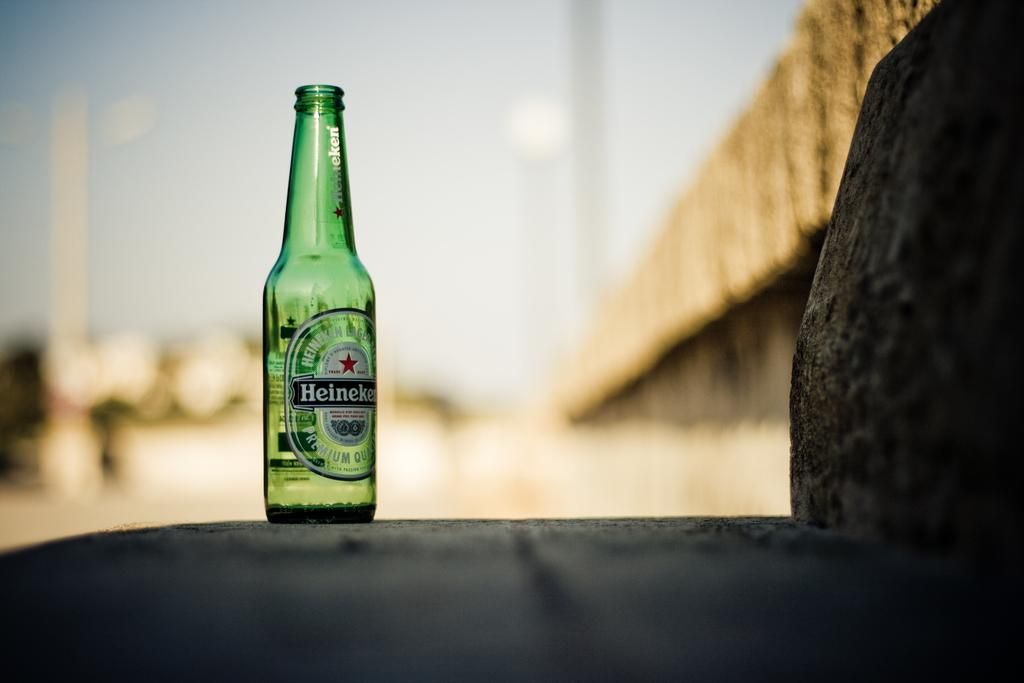Provide a one-sentence caption for the provided image. a bottle of heineken that is open and on a rock. 